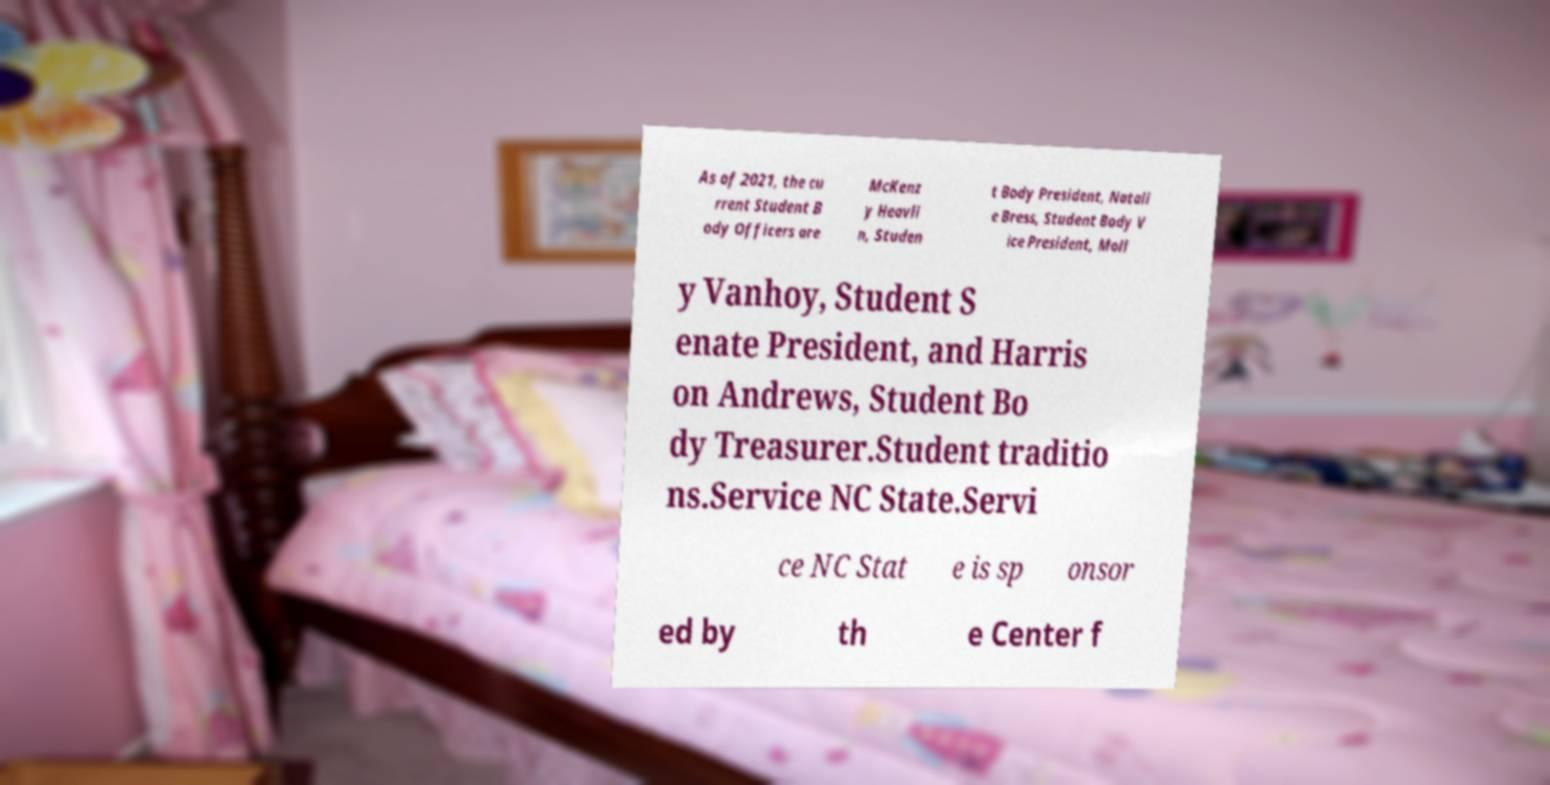I need the written content from this picture converted into text. Can you do that? As of 2021, the cu rrent Student B ody Officers are McKenz y Heavli n, Studen t Body President, Natali e Bress, Student Body V ice President, Moll y Vanhoy, Student S enate President, and Harris on Andrews, Student Bo dy Treasurer.Student traditio ns.Service NC State.Servi ce NC Stat e is sp onsor ed by th e Center f 